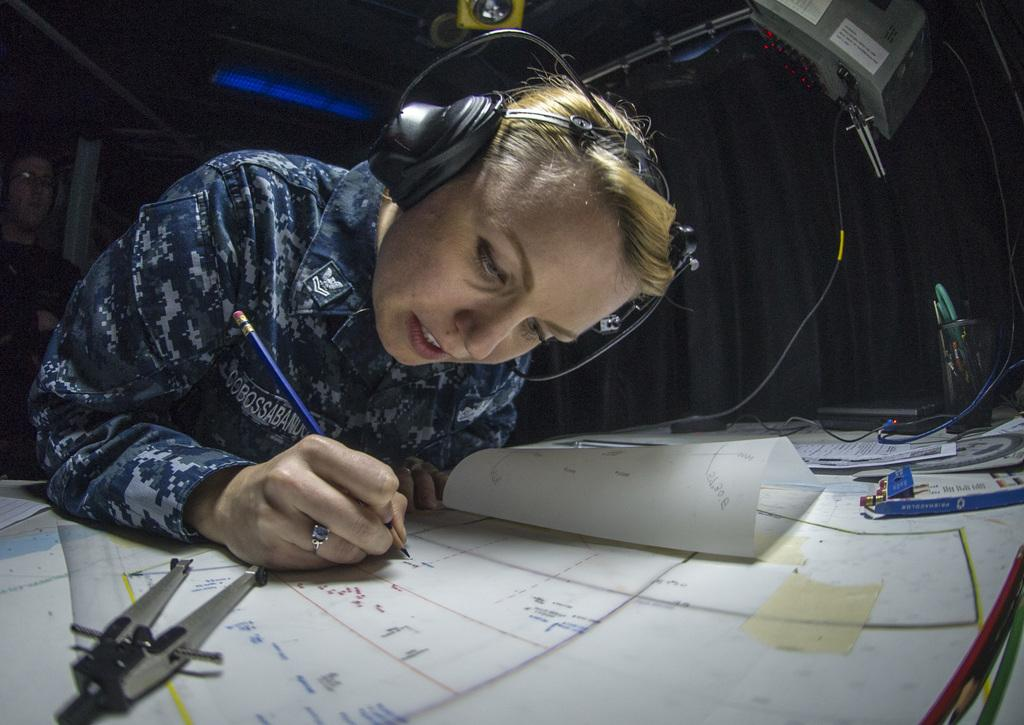Who is present in the image? There is a woman in the image. What is the woman doing in the image? The woman is sitting on a chair and writing on the charts. What is on the table in front of the woman? Charts are placed on the table. What is the woman using to write on the charts? The woman is writing on the charts with a pen or pencil, which is not explicitly mentioned in the facts. Can you see any mittens on the woman's hands in the image? No, there are no mittens visible on the woman's hands in the image. Does the woman have a tail in the image? No, the woman does not have a tail in the image. 